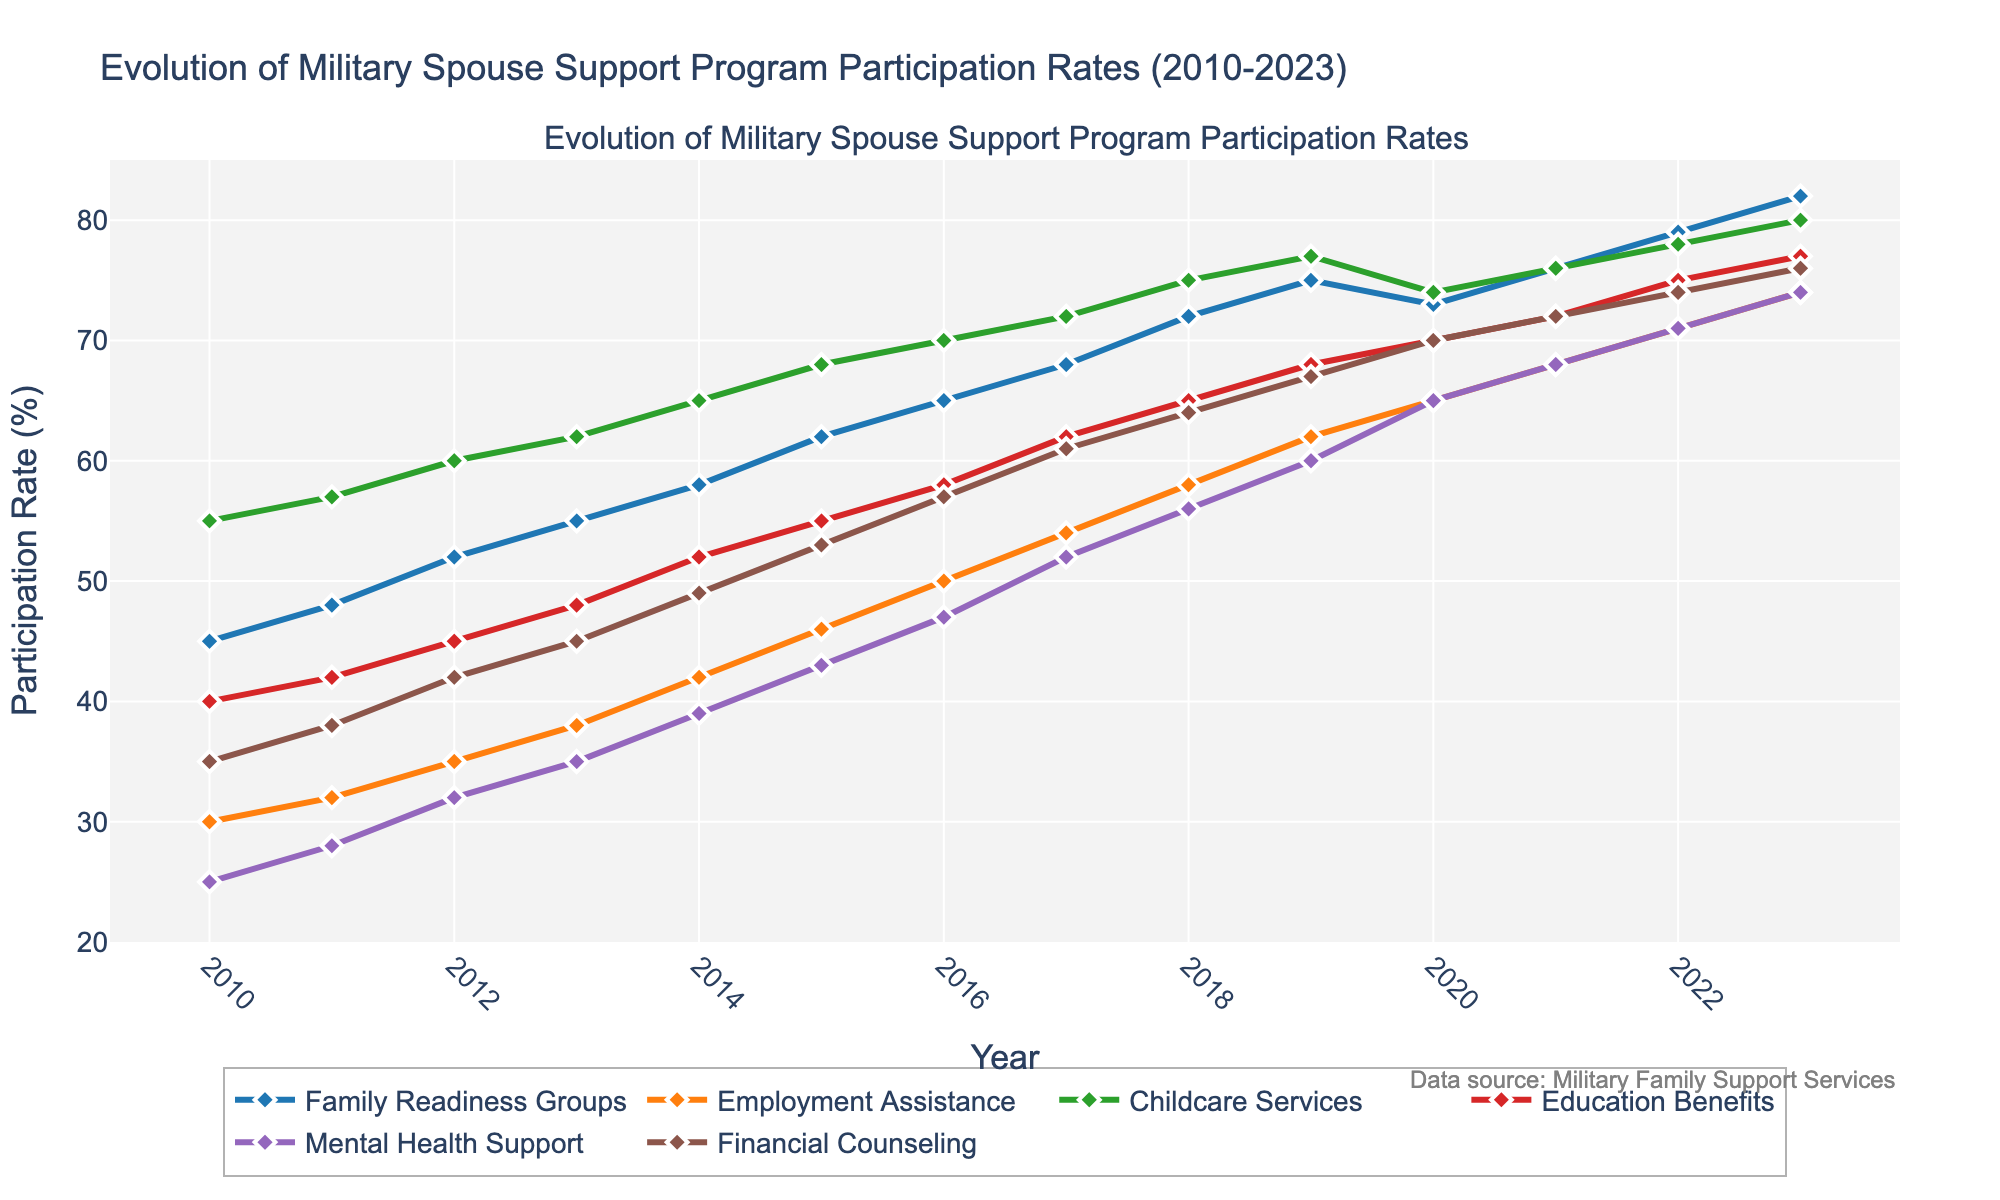What's the highest participation rate recorded for Employment Assistance? The highest participation rate for Employment Assistance can be found by looking at the peak value of the Employment Assistance line. The line peaks in 2023 at a value of 74.
Answer: 74 Which year had the largest increase in Family Readiness Groups participation rate compared to the previous year? To find the largest increase, calculate the year-on-year differences. The differences for Family Readiness Groups are 3, 4, 3, 3, 4, 4, 3, 3, 4, 3, -2, 3, and 3. The largest increase is 4, occurring between 2014 to 2015 and 2017 to 2018.
Answer: 2014 to 2015 and 2017 to 2018 Between 2010 and 2023, which program type saw the biggest overall increase in participation rate? To determine the biggest overall increase, subtract the 2010 values from the 2023 values for each program. The increases are: 
Family Readiness Groups: 82 - 45 = 37,
Employment Assistance: 74 - 30 = 44,
Childcare Services: 80 - 55 = 25,
Education Benefits: 77 - 40 = 37,
Mental Health Support: 74 - 25 = 49,
Financial Counseling: 76 - 35 = 41.
The biggest overall increase is in Mental Health Support, which increased by 49 points.
Answer: Mental Health Support On average, how did the participation rate for Education Benefits change each year from 2010 to 2023? To find the average annual change, first calculate the total change from 2010 to 2023 for Education Benefits: 77 - 40 = 37. There are 13 years between 2010 and 2023. The average annual change is 37 / 13 ≈ 2.85.
Answer: 2.85 Which program had the smallest participation rate in 2015? Observing the 2015 data points, the participation rates are: Family Readiness Groups: 62, Employment Assistance: 46, Childcare Services: 68, Education Benefits: 55, Mental Health Support: 43, and Financial Counseling: 53. The smallest rate is for Mental Health Support at 43.
Answer: Mental Health Support Can you identify a year when the participation rate for both Employment Assistance and Education Benefits were equal? By checking the participation rates year by year, it appears that in no year did the rates for Employment Assistance and Education Benefits match exactly.
Answer: No By how much did the participation rate for Financial Counseling change from 2019 to 2020? The participation rate for Financial Counseling in 2019 was 67, and in 2020 it was 70. The change is 70 - 67 = 3.
Answer: 3 